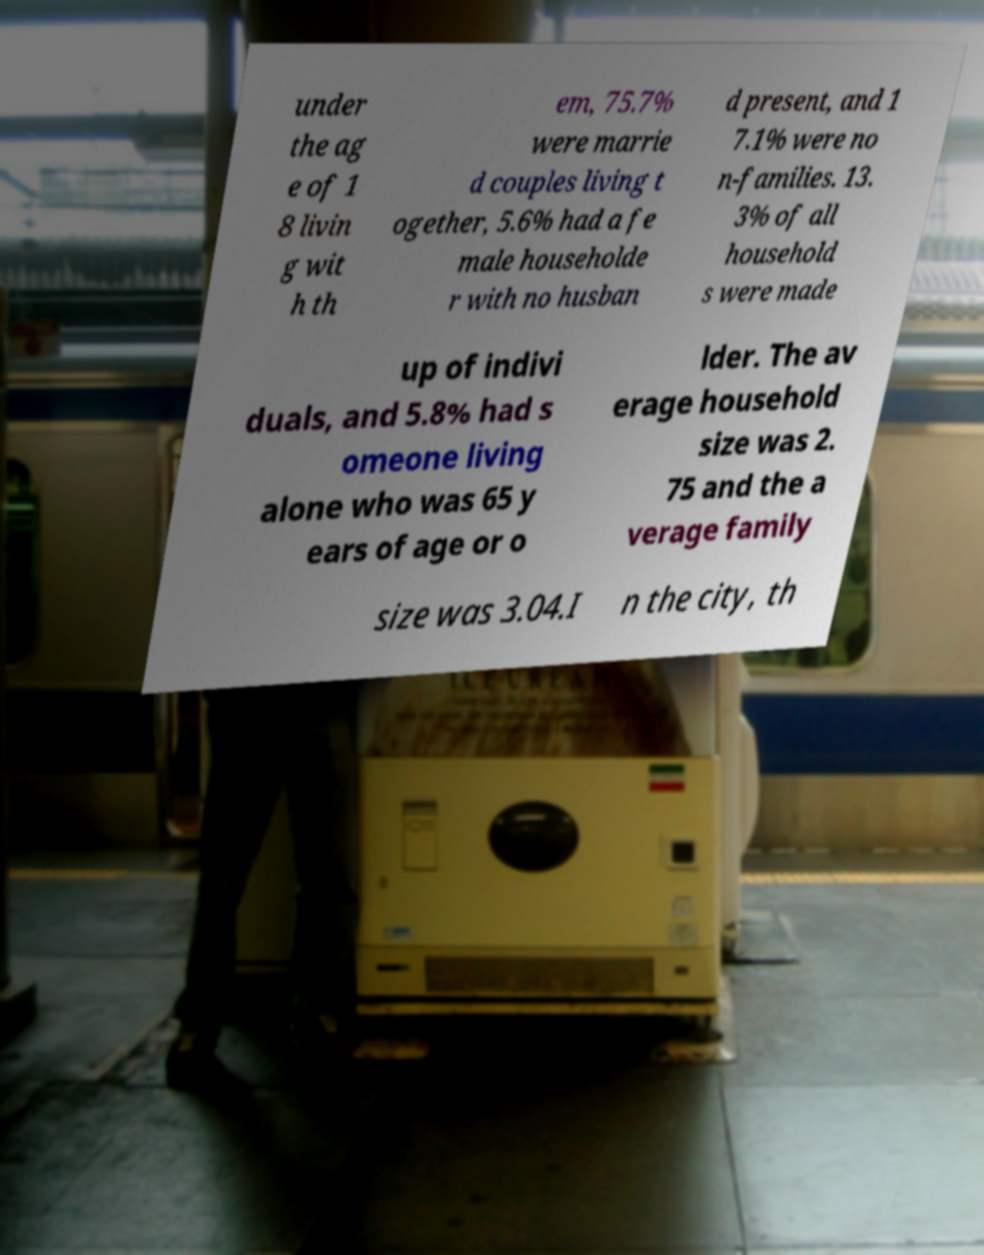I need the written content from this picture converted into text. Can you do that? under the ag e of 1 8 livin g wit h th em, 75.7% were marrie d couples living t ogether, 5.6% had a fe male householde r with no husban d present, and 1 7.1% were no n-families. 13. 3% of all household s were made up of indivi duals, and 5.8% had s omeone living alone who was 65 y ears of age or o lder. The av erage household size was 2. 75 and the a verage family size was 3.04.I n the city, th 